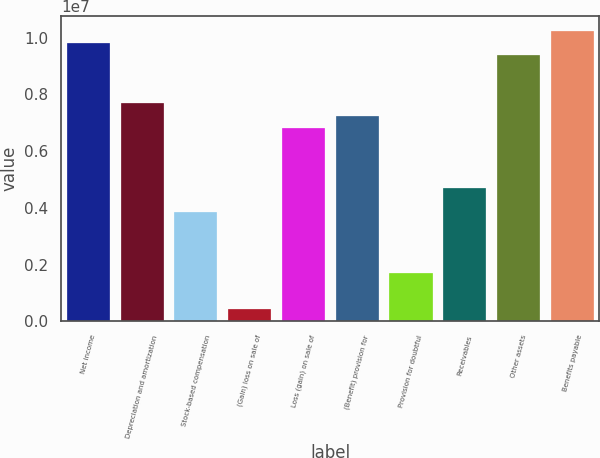Convert chart. <chart><loc_0><loc_0><loc_500><loc_500><bar_chart><fcel>Net income<fcel>Depreciation and amortization<fcel>Stock-based compensation<fcel>(Gain) loss on sale of<fcel>Loss (gain) on sale of<fcel>(Benefit) provision for<fcel>Provision for doubtful<fcel>Receivables<fcel>Other assets<fcel>Benefits payable<nl><fcel>9.81836e+06<fcel>7.68407e+06<fcel>3.84236e+06<fcel>427512<fcel>6.83036e+06<fcel>7.25722e+06<fcel>1.70808e+06<fcel>4.69608e+06<fcel>9.3915e+06<fcel>1.02452e+07<nl></chart> 